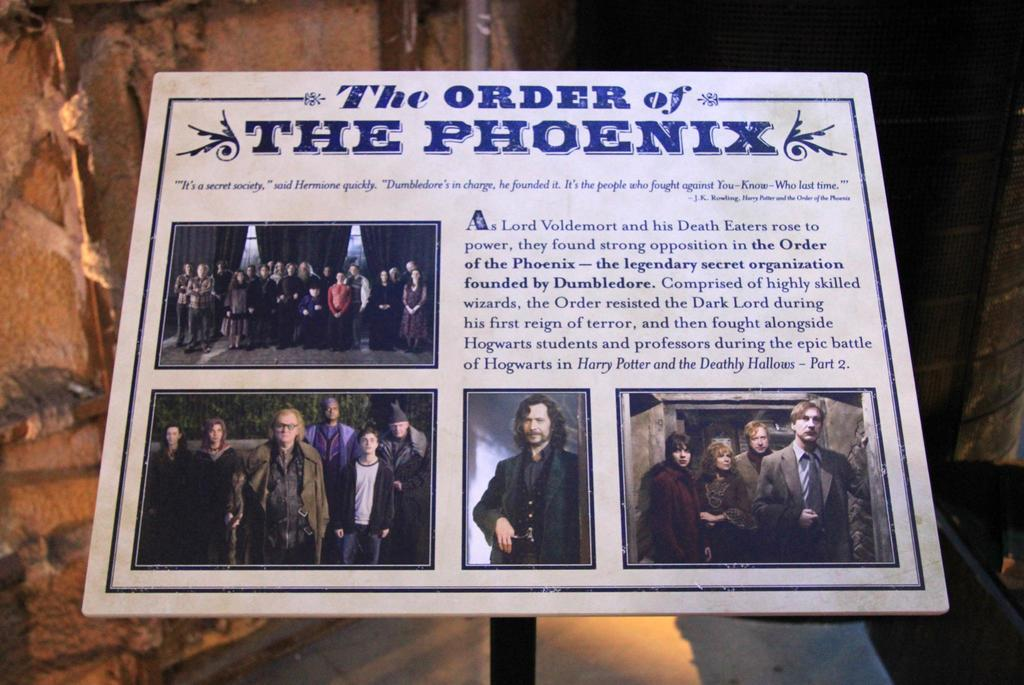<image>
Write a terse but informative summary of the picture. An album by The Order of the Phoenix is white with blue letters. 